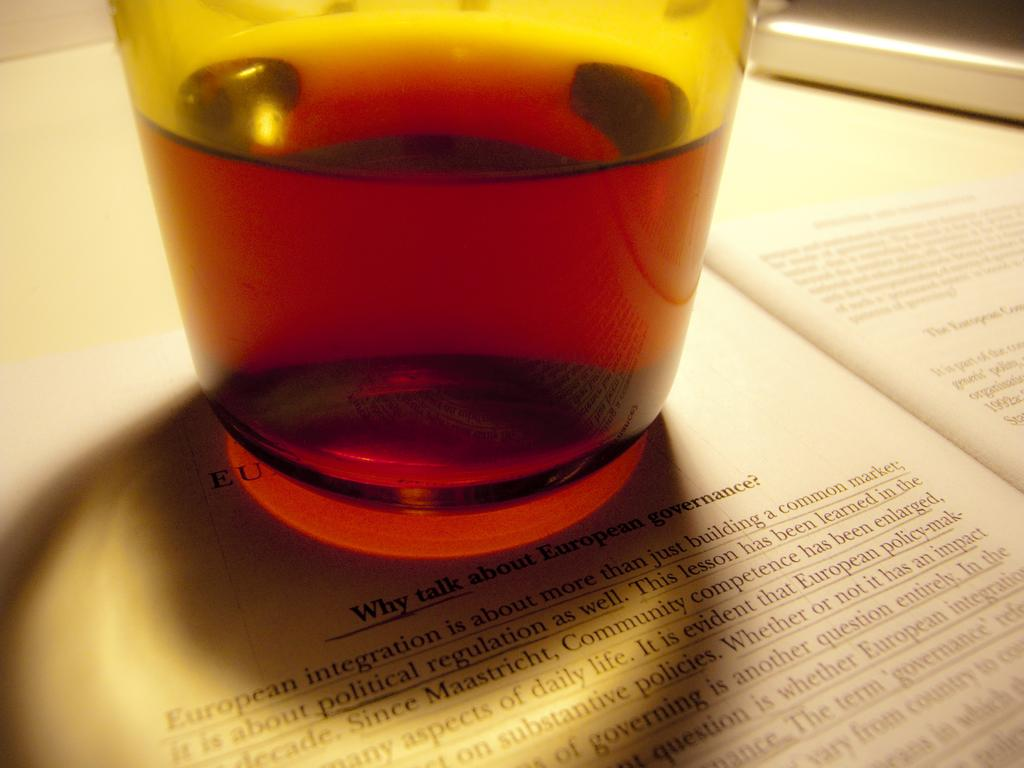<image>
Summarize the visual content of the image. The first word in a paragraph in an open book page is European. 